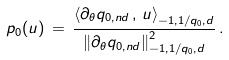Convert formula to latex. <formula><loc_0><loc_0><loc_500><loc_500>p _ { 0 } ( u ) \, = \, \frac { \left \langle \partial _ { \theta } q _ { 0 , n d } \, , \, u \right \rangle _ { - 1 , 1 / q _ { 0 } , d } } { \left \| \partial _ { \theta } q _ { 0 , n d } \right \| _ { - 1 , 1 / q _ { 0 } , d } ^ { 2 } } \, .</formula> 